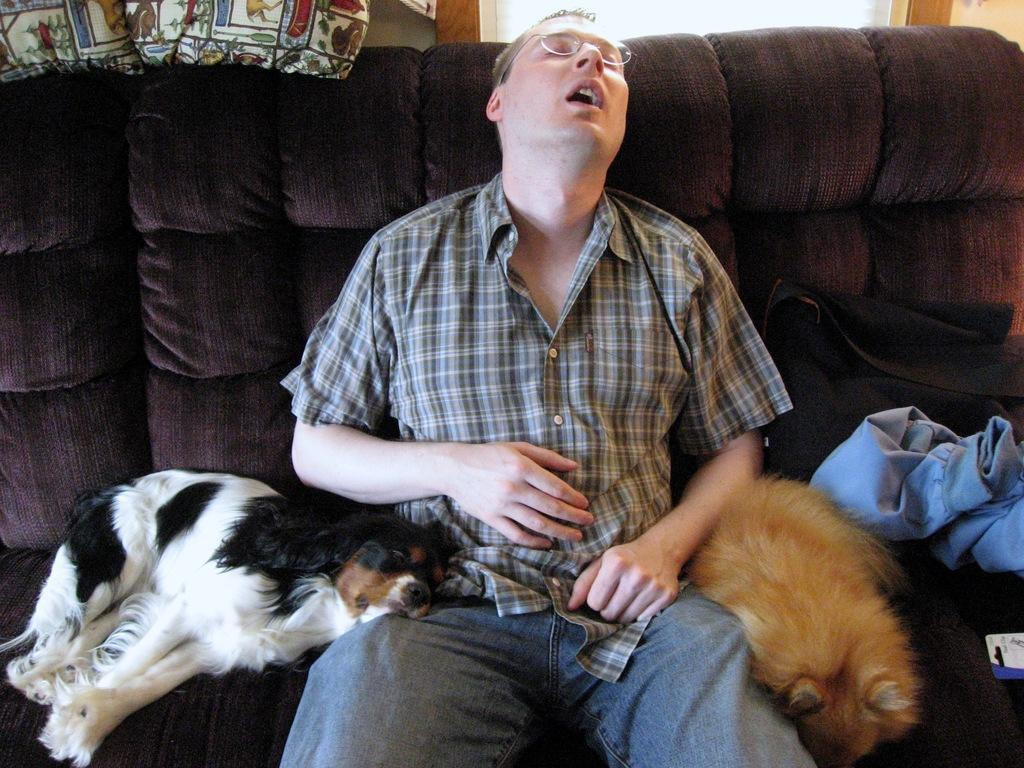Who is present in the image? There is a man in the image. What is the man doing in the image? The man is sitting on a couch. Are there any other living beings in the image besides the man? Yes, there are two animals beside the man. What type of beetle can be seen crawling on the man's arm in the image? There is no beetle present on the man's arm in the image. 